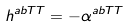<formula> <loc_0><loc_0><loc_500><loc_500>h ^ { a b T T } = - \alpha ^ { a b T T }</formula> 